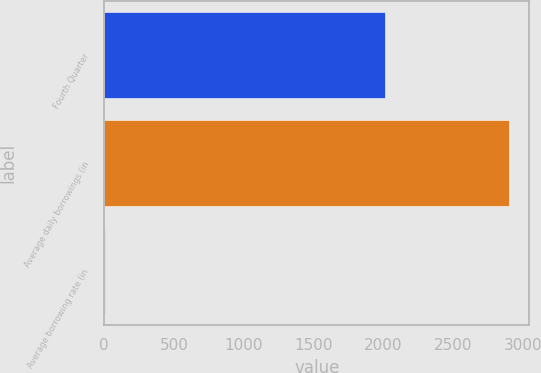<chart> <loc_0><loc_0><loc_500><loc_500><bar_chart><fcel>Fourth Quarter<fcel>Average daily borrowings (in<fcel>Average borrowing rate (in<nl><fcel>2008<fcel>2900<fcel>5.9<nl></chart> 